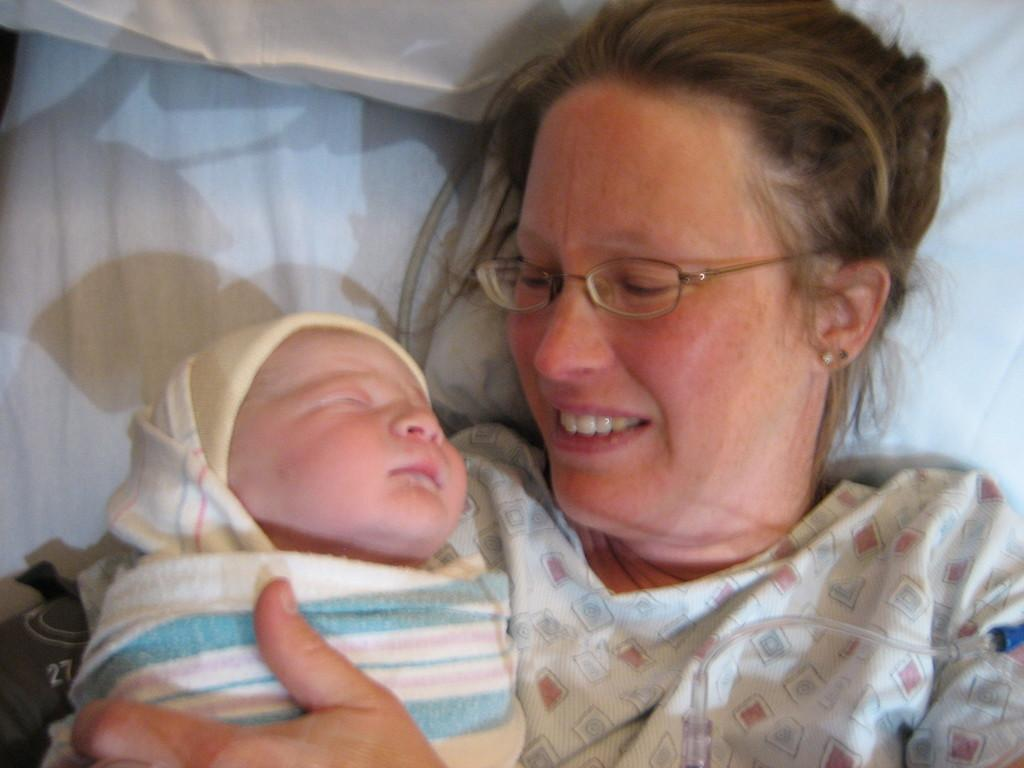Who is the main subject in the image? There is a woman in the image. What is the woman doing in the image? The woman is lying on a bed. Is there anyone else in the image besides the woman? Yes, the woman is holding a baby in her arms. What type of shoes is the woman wearing in the image? There is no mention of shoes in the image, so we cannot determine what type of shoes the woman might be wearing. 